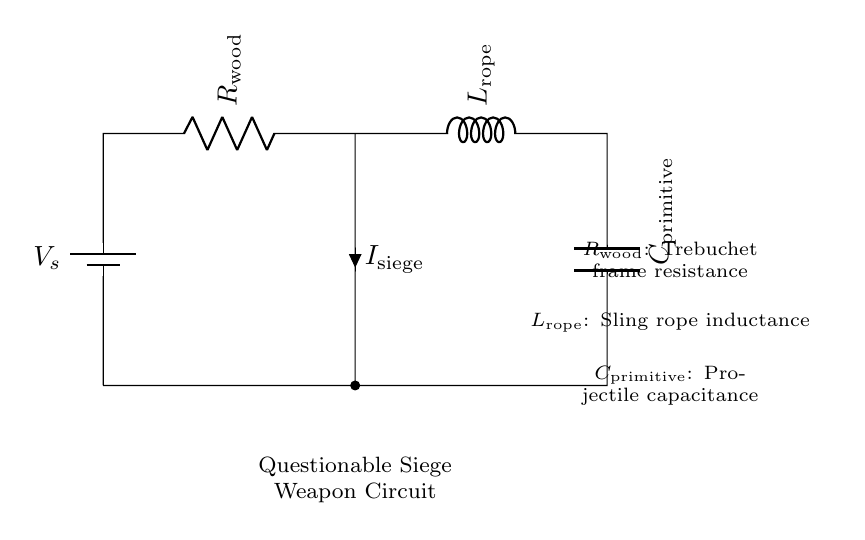What is the resistance labeled in the circuit? The resistance in the circuit is labeled as R_wood, indicating it represents the frame resistance of a trebuchet.
Answer: R_wood What component represents the inductance in this circuit? The component that represents the inductance is labeled as L_rope, which signifies the inductance associated with the sling rope in the siege weapon.
Answer: L_rope What does C_primitive represent in this circuit? C_primitive represents the capacitance of the projectile, indicating its ability to store electrical energy, analogous to how a capacitor would operate in an electrical circuit.
Answer: C_primitive How many components are in the circuit? The circuit consists of three components: a resistor, an inductor, and a capacitor, indicated by the labels present in the diagram.
Answer: 3 What direction does the current flow in the circuit? The current I_siege flows from the resistor R_wood downward through the circuit, indicating the pathway of the current from the voltage source to the capacitor.
Answer: Downward What can be inferred about the functionality of C_primitive in historical battles? C_primitive, as a component in this siege weapon circuit, may not have effective energy storage, raising questions about the practical utility and effectiveness of primitive capacitor designs in significant historical conflicts.
Answer: Questionable effectiveness 